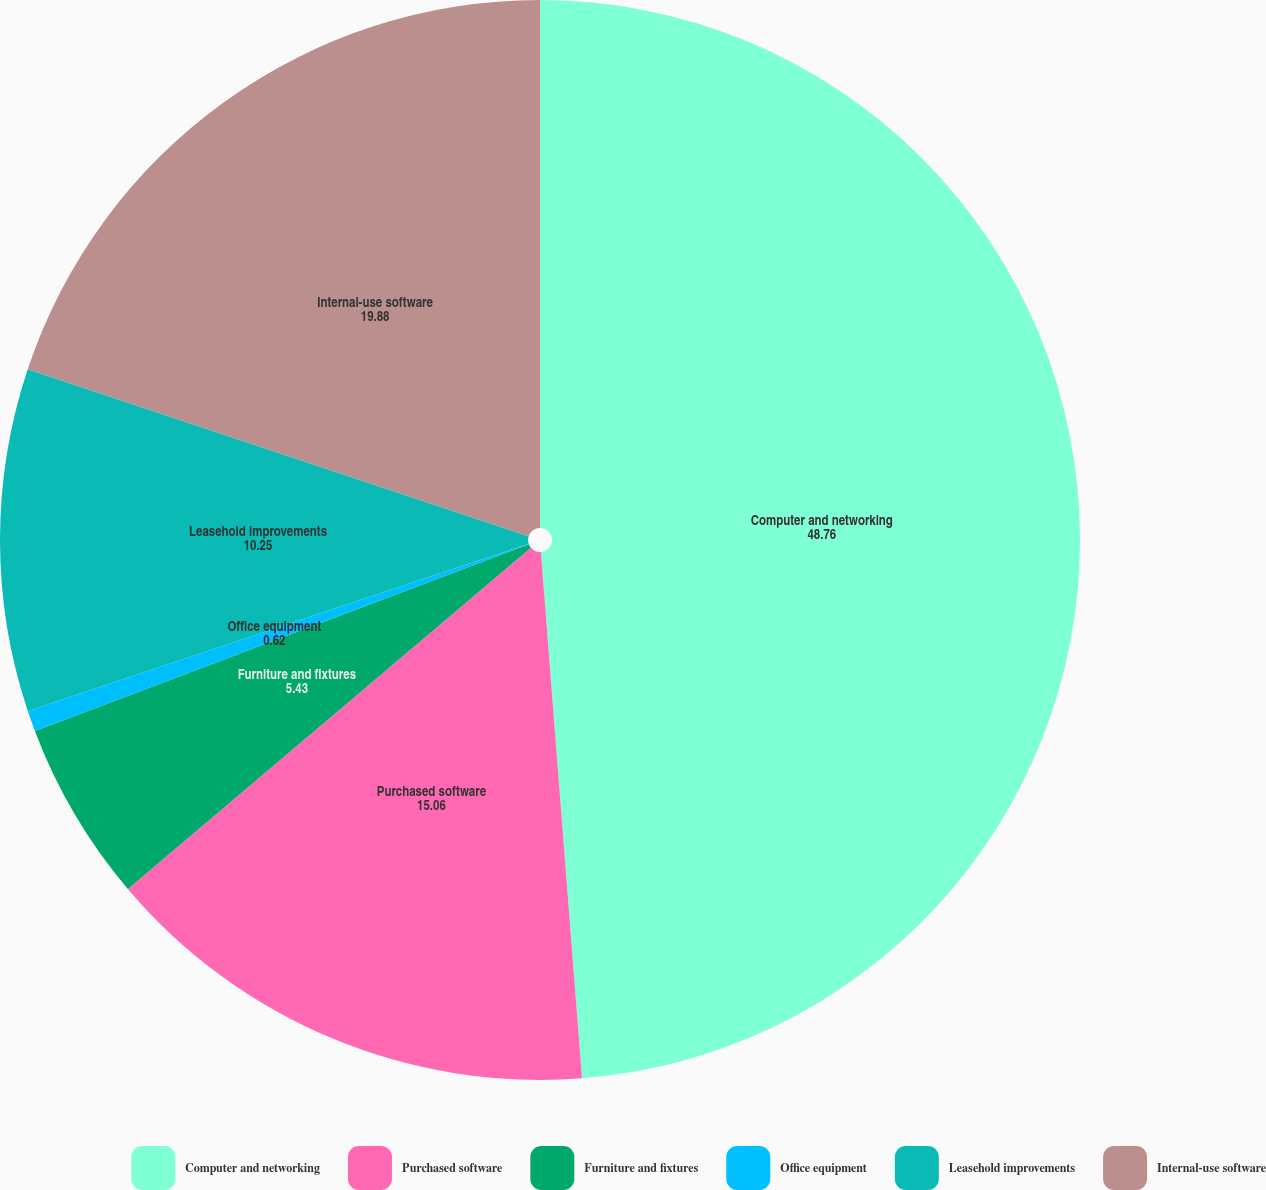Convert chart to OTSL. <chart><loc_0><loc_0><loc_500><loc_500><pie_chart><fcel>Computer and networking<fcel>Purchased software<fcel>Furniture and fixtures<fcel>Office equipment<fcel>Leasehold improvements<fcel>Internal-use software<nl><fcel>48.76%<fcel>15.06%<fcel>5.43%<fcel>0.62%<fcel>10.25%<fcel>19.88%<nl></chart> 